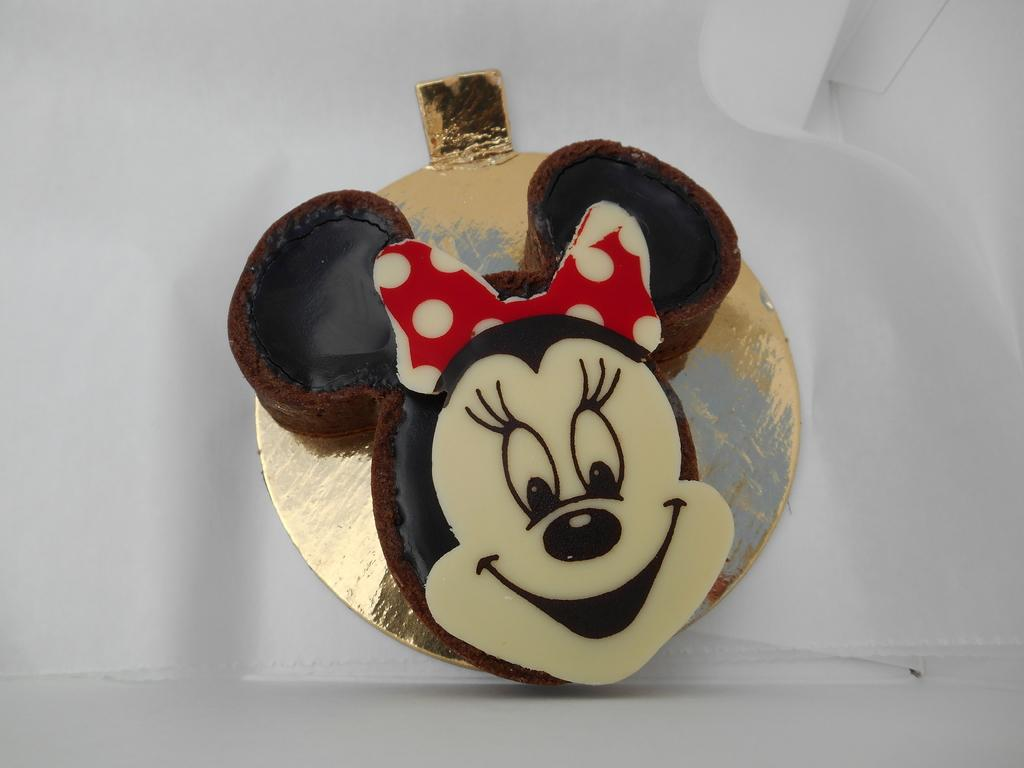What type of cake is shown in the image? There is a Mickey-Mouse cake in the image. What is the cake placed on? The cake is on a gold and silver color board. What color is the background of the image? The background of the image is white. How does the cake grip the mask in the image? There is no mask present in the image, and therefore no interaction between the cake and a mask can be observed. 